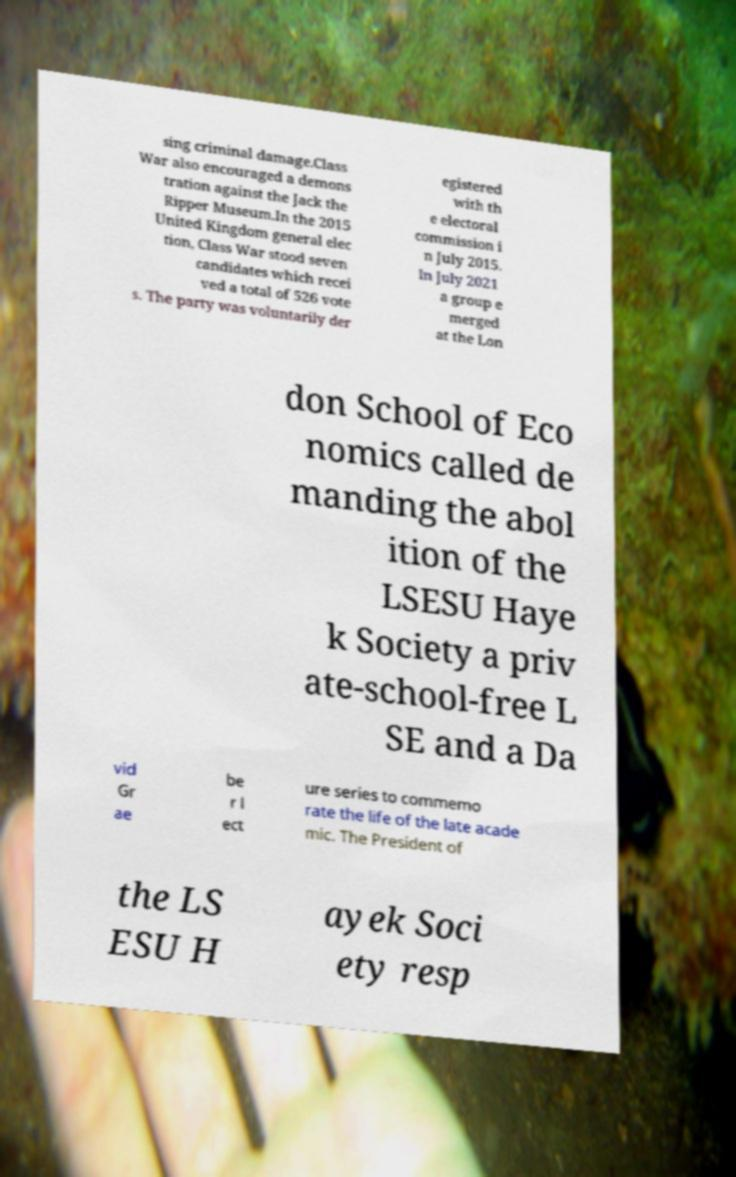What messages or text are displayed in this image? I need them in a readable, typed format. sing criminal damage.Class War also encouraged a demons tration against the Jack the Ripper Museum.In the 2015 United Kingdom general elec tion, Class War stood seven candidates which recei ved a total of 526 vote s. The party was voluntarily der egistered with th e electoral commission i n July 2015. In July 2021 a group e merged at the Lon don School of Eco nomics called de manding the abol ition of the LSESU Haye k Society a priv ate-school-free L SE and a Da vid Gr ae be r l ect ure series to commemo rate the life of the late acade mic. The President of the LS ESU H ayek Soci ety resp 